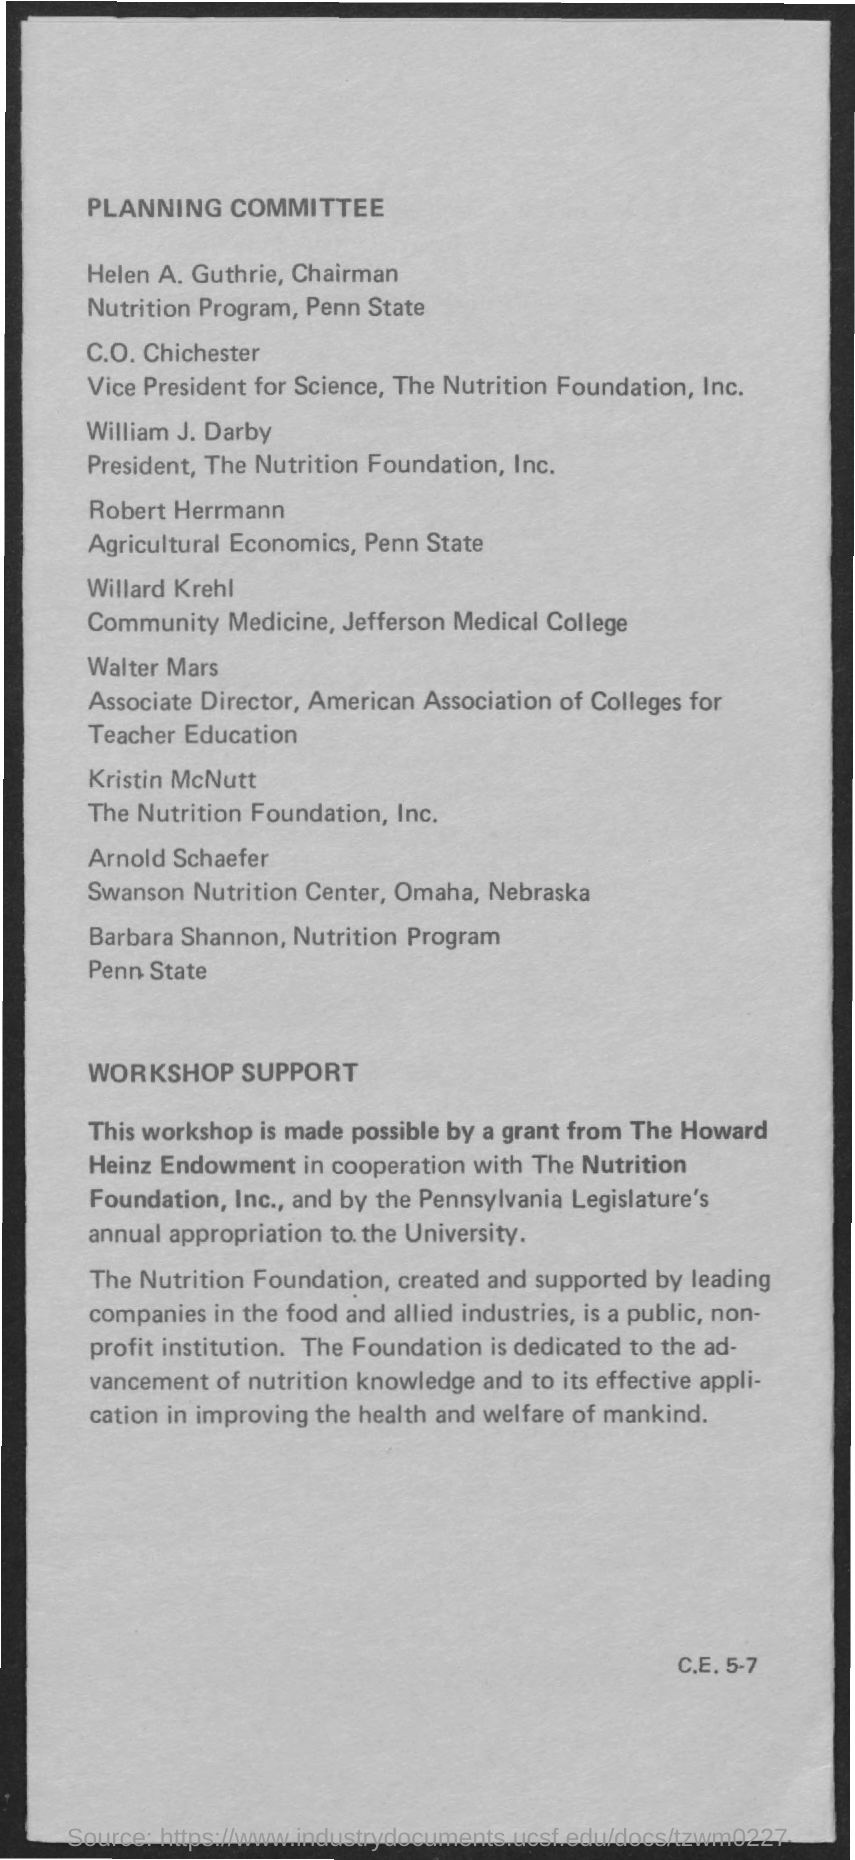Who is the chairman of nutrition program , penn state
Your answer should be compact. Helen A. Guthrie. Who is the president  of  the nutrition foundation , inc
Make the answer very short. William J. Darby. 